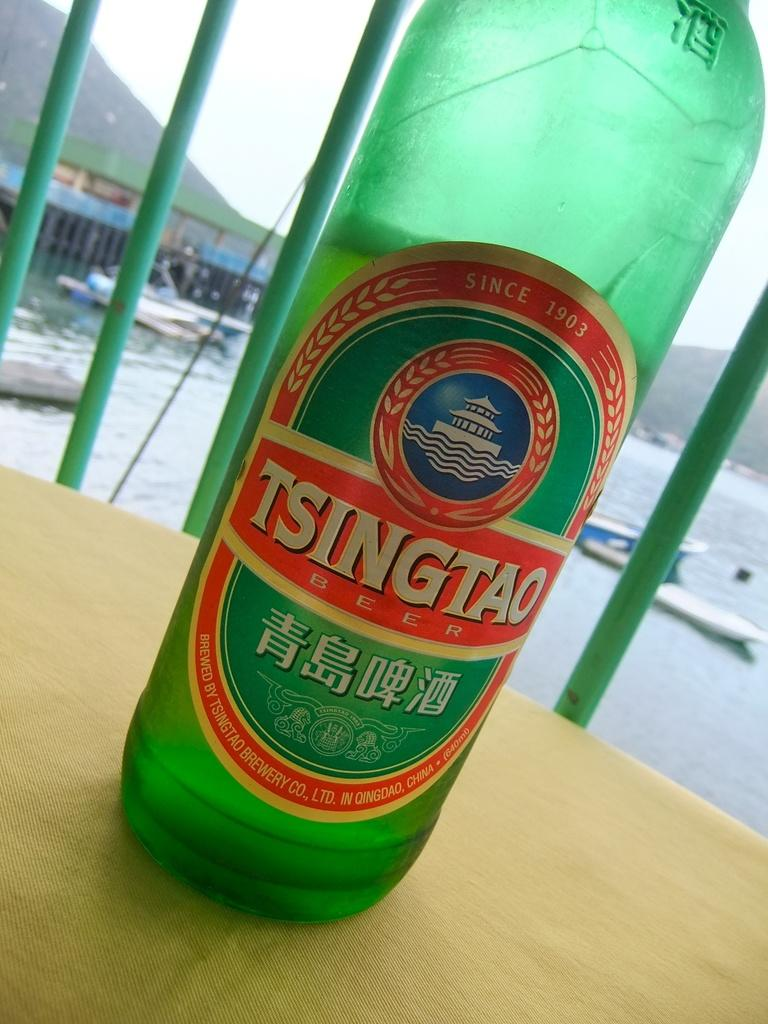What object is present in the image that can hold a liquid? There is a bottle in the image that can hold a liquid. What is inside the bottle? The bottle contains water. What type of vehicles can be seen in the image? There are boats in the image. What can be seen in the background of the image? There is a sky and a mountain visible in the background of the image. What type of arch can be seen in the image? There is no arch present in the image. What color is the rat's underwear in the image? There is no rat or underwear present in the image. 